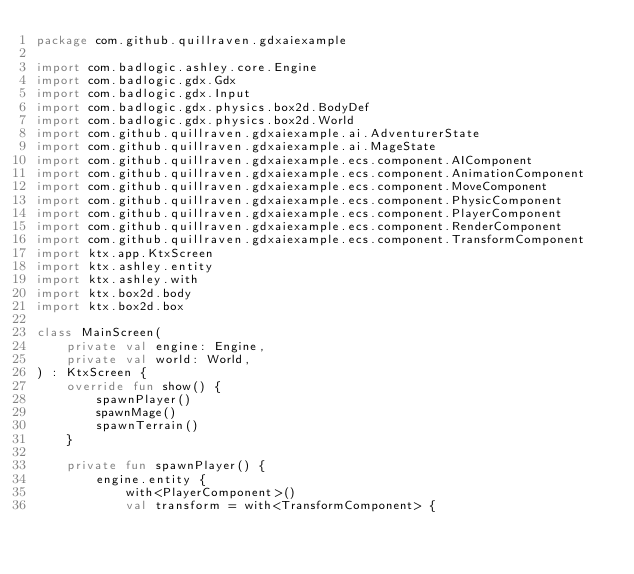<code> <loc_0><loc_0><loc_500><loc_500><_Kotlin_>package com.github.quillraven.gdxaiexample

import com.badlogic.ashley.core.Engine
import com.badlogic.gdx.Gdx
import com.badlogic.gdx.Input
import com.badlogic.gdx.physics.box2d.BodyDef
import com.badlogic.gdx.physics.box2d.World
import com.github.quillraven.gdxaiexample.ai.AdventurerState
import com.github.quillraven.gdxaiexample.ai.MageState
import com.github.quillraven.gdxaiexample.ecs.component.AIComponent
import com.github.quillraven.gdxaiexample.ecs.component.AnimationComponent
import com.github.quillraven.gdxaiexample.ecs.component.MoveComponent
import com.github.quillraven.gdxaiexample.ecs.component.PhysicComponent
import com.github.quillraven.gdxaiexample.ecs.component.PlayerComponent
import com.github.quillraven.gdxaiexample.ecs.component.RenderComponent
import com.github.quillraven.gdxaiexample.ecs.component.TransformComponent
import ktx.app.KtxScreen
import ktx.ashley.entity
import ktx.ashley.with
import ktx.box2d.body
import ktx.box2d.box

class MainScreen(
    private val engine: Engine,
    private val world: World,
) : KtxScreen {
    override fun show() {
        spawnPlayer()
        spawnMage()
        spawnTerrain()
    }

    private fun spawnPlayer() {
        engine.entity {
            with<PlayerComponent>()
            val transform = with<TransformComponent> {</code> 